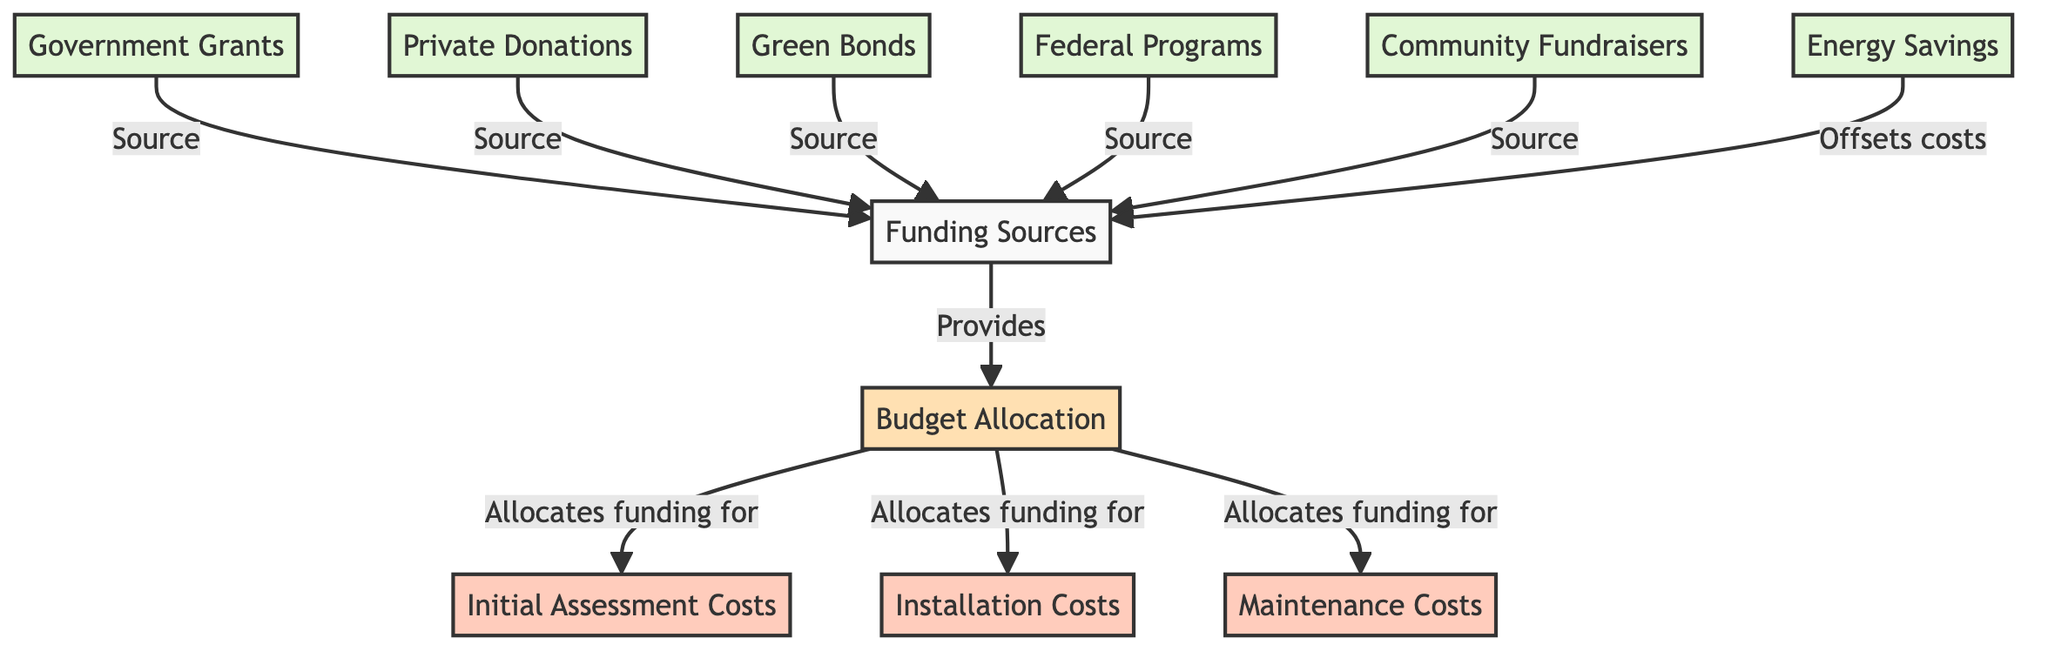What is the primary focus of the diagram? The diagram centers around the relationship between budget allocation and funding sources, particularly highlighting how different funding sources contribute to the budget.
Answer: Budget Allocation and Funding Sources How many funding sources are listed in the diagram? The diagram lists five distinct funding sources that provide contributions towards the budget allocation.
Answer: Five What costs are allocated funding from the budget? Upon reviewing the connections from the budget allocation node, it is evident that funding is allocated to initial assessment costs, installation costs, and maintenance costs.
Answer: Initial Assessment Costs, Installation Costs, Maintenance Costs Which funding source is related to government assistance? The diagram specifies government grants as a direct funding source, illustrating its connection to budget allocation.
Answer: Government Grants What is the relationship between energy savings and budget allocation? The diagram indicates that energy savings act as an offset to costs within the budget allocation, suggesting their potential to reduce overall expenditures.
Answer: Offsets costs Which nodes provide funding to the budget allocation? By examining incoming edges to the budget allocation node, it is found that government grants, private donations, green bonds, federal programs, and community fundraisers all provide funding to the budget allocation.
Answer: Government Grants, Private Donations, Green Bonds, Federal Programs, Community Fundraisers How many total edges connect nodes in the diagram? The total number of edges can be determined by counting all directed connections, which include those from funding sources to the budget allocation and costs. The total is ten edges.
Answer: Ten What type of costs does the budget allocate funding for? The diagram outlines three specific types of costs—initial assessment costs, installation costs, and maintenance costs—each receiving funding from the budget allocation.
Answer: Initial Assessment Costs, Installation Costs, Maintenance Costs Which node contributes the most diverse sources of funding? The funding sources node itself encompasses multiple distinct sources including government grants, private donations, green bonds, federal programs, and community fundraisers, marking it as the most diverse.
Answer: Funding Sources 